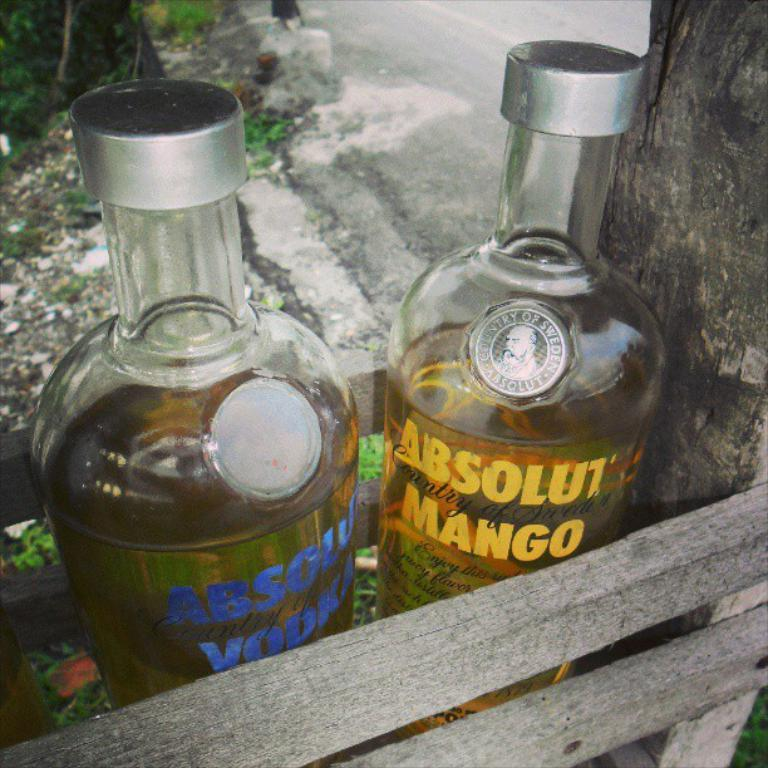How many bottles are visible in the image? There are two bottles in the image. What else can be seen in the image besides the bottles? There is a branch and a road visible in the image. What type of loaf is being carried by the truck in the image? There is no truck or loaf present in the image. What caption is written on the branch in the image? There is no caption written on the branch in the image; it is a natural object. 